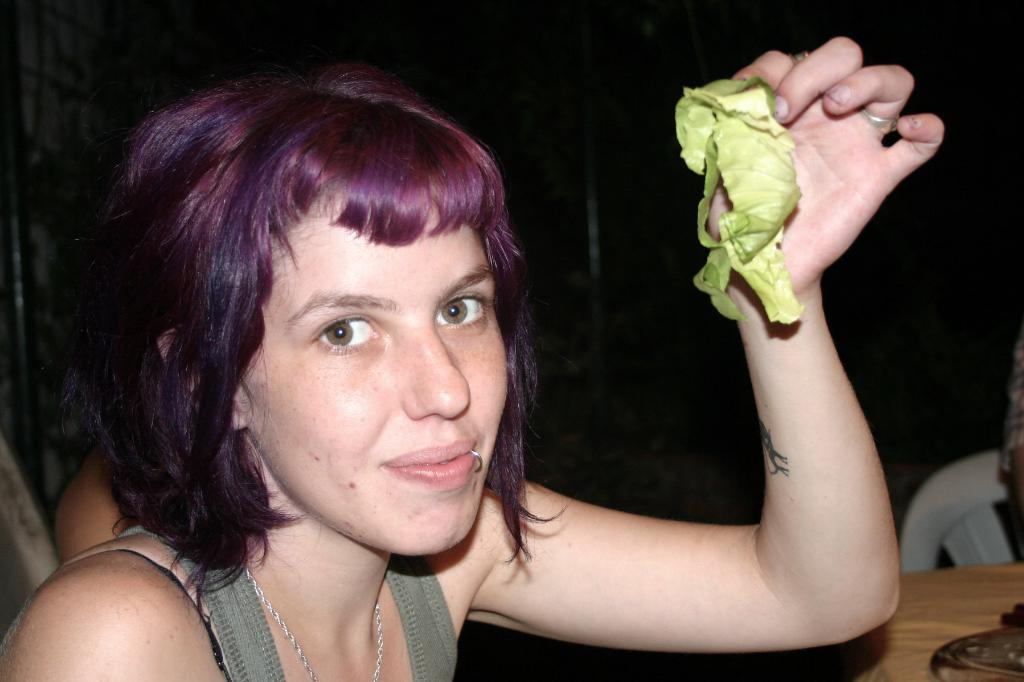Who is present in the image? There is a woman in the image. What is the woman holding in the image? The woman is holding a vegetable. What piece of furniture can be seen in the image? There is a chair in the image. What is on the table in the image? There is an object on the table. How would you describe the lighting in the image? The background of the image is dark. Can you see a goat on the edge of the table in the image? There is no goat present in the image, and the edge of the table is not visible. 